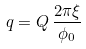Convert formula to latex. <formula><loc_0><loc_0><loc_500><loc_500>q = Q \, \frac { 2 \pi \xi } { \phi _ { 0 } }</formula> 